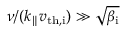<formula> <loc_0><loc_0><loc_500><loc_500>\nu / ( k _ { \| } v _ { t h , i } ) \gg \sqrt { \beta _ { i } }</formula> 